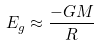Convert formula to latex. <formula><loc_0><loc_0><loc_500><loc_500>E _ { g } \approx \frac { - G M } { R }</formula> 